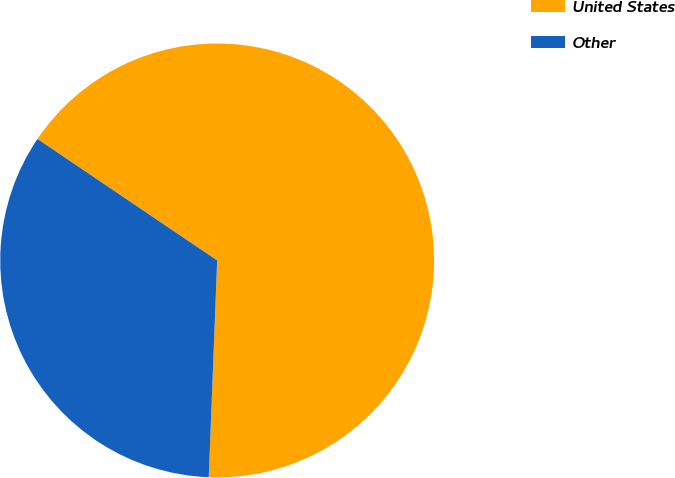<chart> <loc_0><loc_0><loc_500><loc_500><pie_chart><fcel>United States<fcel>Other<nl><fcel>66.16%<fcel>33.84%<nl></chart> 